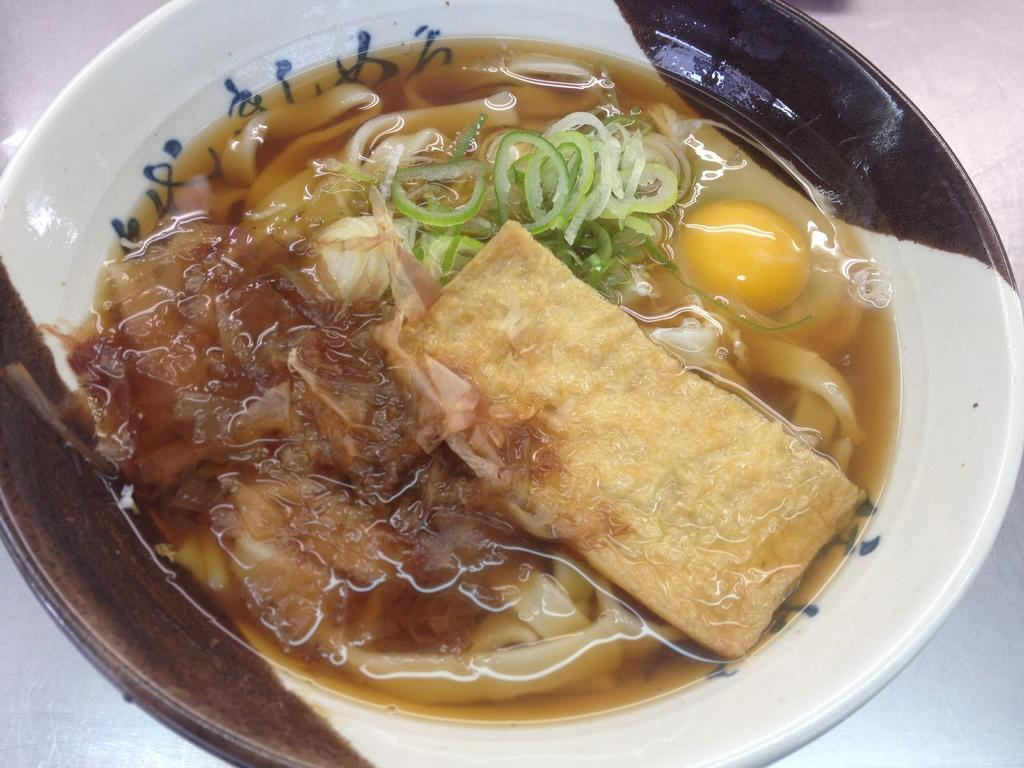What is present on the plate in the image? The plate contains different types of food. Can you describe the color of the plate? The color of the plate is white and little bit brown. Is there an owl sitting on the plate in the image? No, there is no owl present in the image. What type of flag is visible in the image? There is no flag visible in the image. 